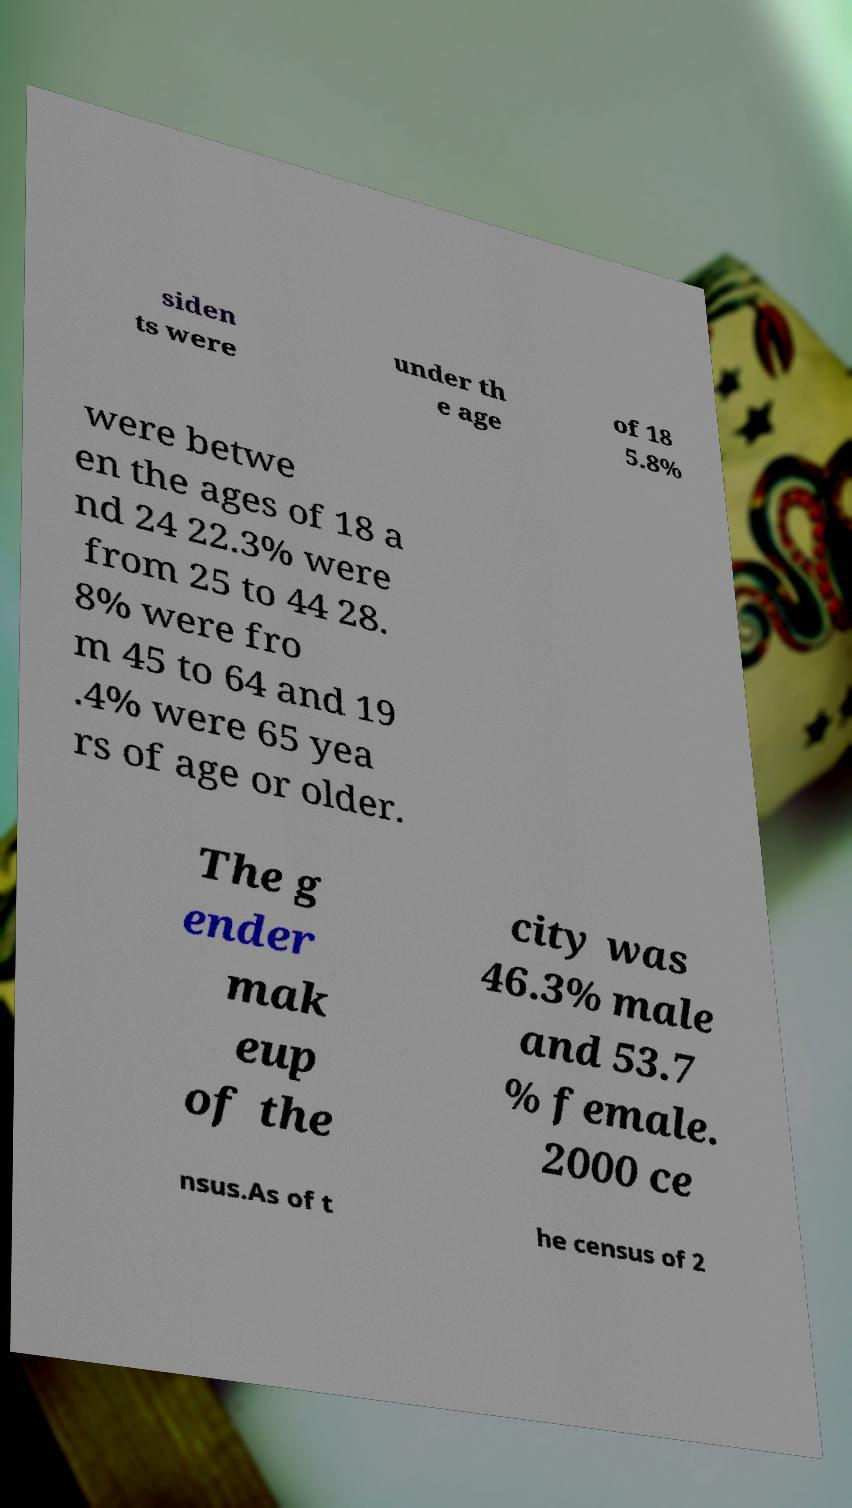Please read and relay the text visible in this image. What does it say? siden ts were under th e age of 18 5.8% were betwe en the ages of 18 a nd 24 22.3% were from 25 to 44 28. 8% were fro m 45 to 64 and 19 .4% were 65 yea rs of age or older. The g ender mak eup of the city was 46.3% male and 53.7 % female. 2000 ce nsus.As of t he census of 2 